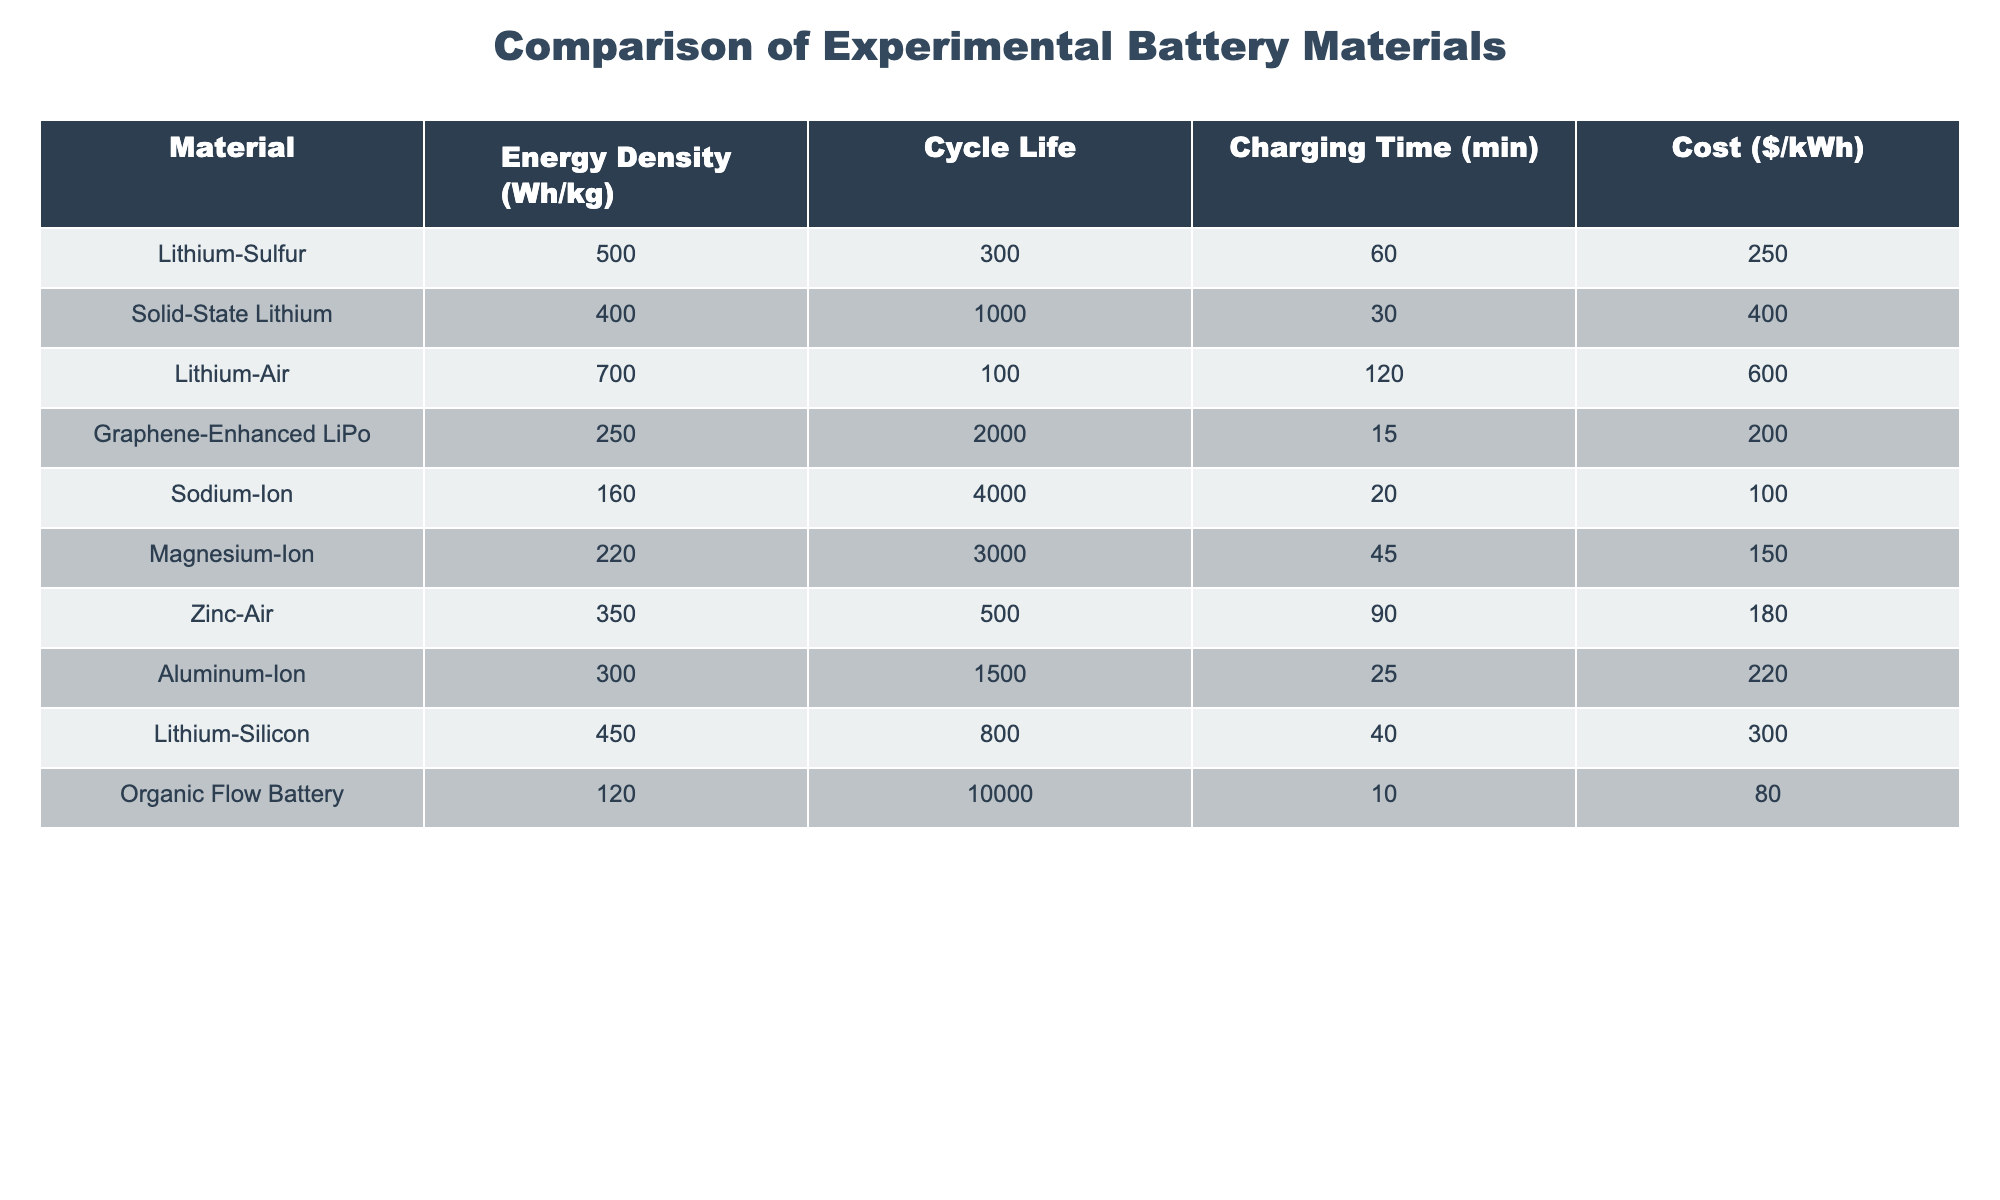What is the energy density of Lithium-Air? The table indicates that Lithium-Air has an energy density of 700 Wh/kg.
Answer: 700 Wh/kg Which material has the longest cycle life? By examining the cycle life column, Sodium-Ion stands out with a cycle life of 4000 cycles, which is the highest in the table.
Answer: Sodium-Ion What is the charging time for the Graphene-Enhanced LiPo battery? Checking the charging time column shows that the Graphene-Enhanced LiPo battery requires 15 minutes to charge.
Answer: 15 minutes Is the energy density of Solid-State Lithium greater than that of Aluminum-Ion? Solid-State Lithium has an energy density of 400 Wh/kg, while Aluminum-Ion has 300 Wh/kg; therefore, the energy density of Solid-State Lithium is greater.
Answer: Yes What is the average energy density of all the materials listed? Summing the energy density values (500 + 400 + 700 + 250 + 160 + 220 + 350 + 300 + 450 + 120) gives a total of 3100 Wh/kg. There are 10 materials, so the average energy density is 3100/10 = 310 Wh/kg.
Answer: 310 Wh/kg Which battery type has the lowest cost per kWh? The table shows that the Organic Flow Battery has the lowest cost of $80 per kWh.
Answer: Organic Flow Battery If you combine the cycle life of Lithium-Sulfur and Magnesium-Ion, what is their total cycle life? The cycle life of Lithium-Sulfur is 300, and for Magnesium-Ion, it is 3000. Adding these together (300 + 3000) gives a total of 3300 cycles.
Answer: 3300 cycles Are all the battery materials listed capable of achieving over 200 Wh/kg? Reviewing the energy density values, Lithium-Sulfur, Lithium-Air, Solid-State Lithium, Graphene-Enhanced LiPo, Aluminum-Ion, Lithium-Silicon, and Zinc-Air all exceed 200 Wh/kg, so not all materials surpass that threshold.
Answer: No What is the difference in charging time between Sodium-Ion and Lithium-Air? Sodium-Ion takes 20 minutes to charge, while Lithium-Air takes 120 minutes. The difference is 120 - 20 = 100 minutes.
Answer: 100 minutes How many materials have a cycle life greater than 1000 cycles? Looking at the cycle life data, Solid-State Lithium (1000), Graphene-Enhanced LiPo (2000), Sodium-Ion (4000), and Magnesium-Ion (3000) all have cycle lives greater than 1000, totaling 4 materials.
Answer: 4 